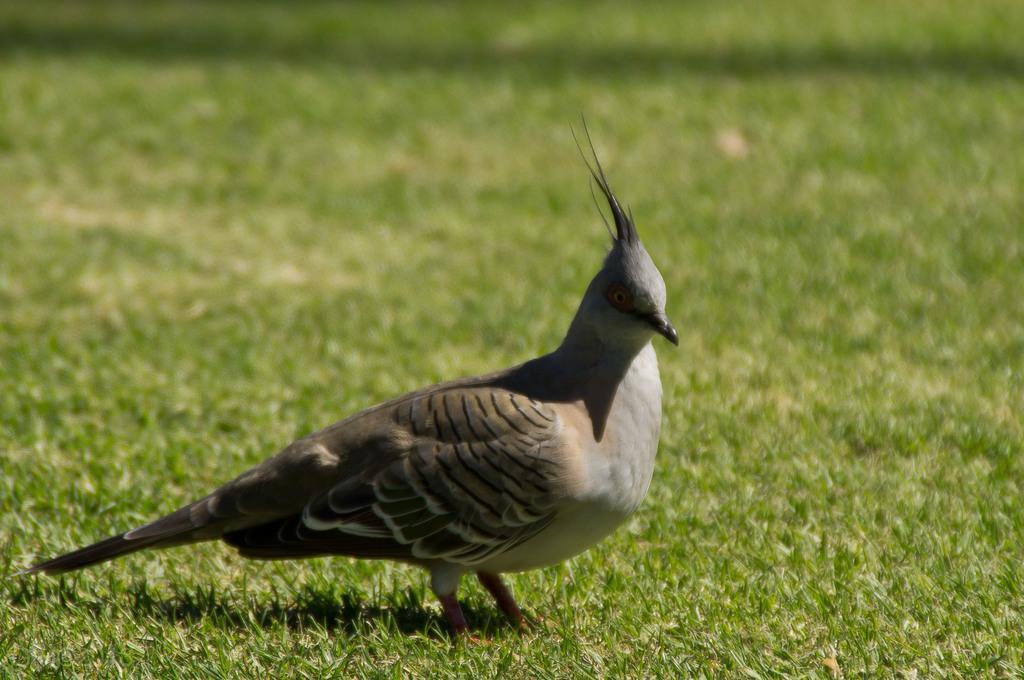Please provide a concise description of this image. In this image we can see a bird standing on the ground. 